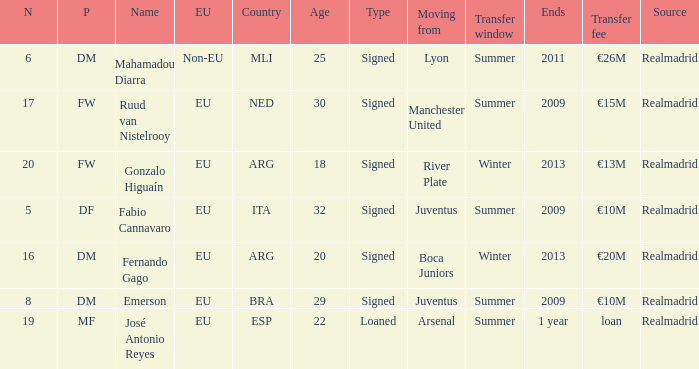Can you give me this table as a dict? {'header': ['N', 'P', 'Name', 'EU', 'Country', 'Age', 'Type', 'Moving from', 'Transfer window', 'Ends', 'Transfer fee', 'Source'], 'rows': [['6', 'DM', 'Mahamadou Diarra', 'Non-EU', 'MLI', '25', 'Signed', 'Lyon', 'Summer', '2011', '€26M', 'Realmadrid'], ['17', 'FW', 'Ruud van Nistelrooy', 'EU', 'NED', '30', 'Signed', 'Manchester United', 'Summer', '2009', '€15M', 'Realmadrid'], ['20', 'FW', 'Gonzalo Higuaín', 'EU', 'ARG', '18', 'Signed', 'River Plate', 'Winter', '2013', '€13M', 'Realmadrid'], ['5', 'DF', 'Fabio Cannavaro', 'EU', 'ITA', '32', 'Signed', 'Juventus', 'Summer', '2009', '€10M', 'Realmadrid'], ['16', 'DM', 'Fernando Gago', 'EU', 'ARG', '20', 'Signed', 'Boca Juniors', 'Winter', '2013', '€20M', 'Realmadrid'], ['8', 'DM', 'Emerson', 'EU', 'BRA', '29', 'Signed', 'Juventus', 'Summer', '2009', '€10M', 'Realmadrid'], ['19', 'MF', 'José Antonio Reyes', 'EU', 'ESP', '22', 'Loaned', 'Arsenal', 'Summer', '1 year', 'loan', 'Realmadrid']]} What is the type of the player whose transfer fee was €20m? Signed. 